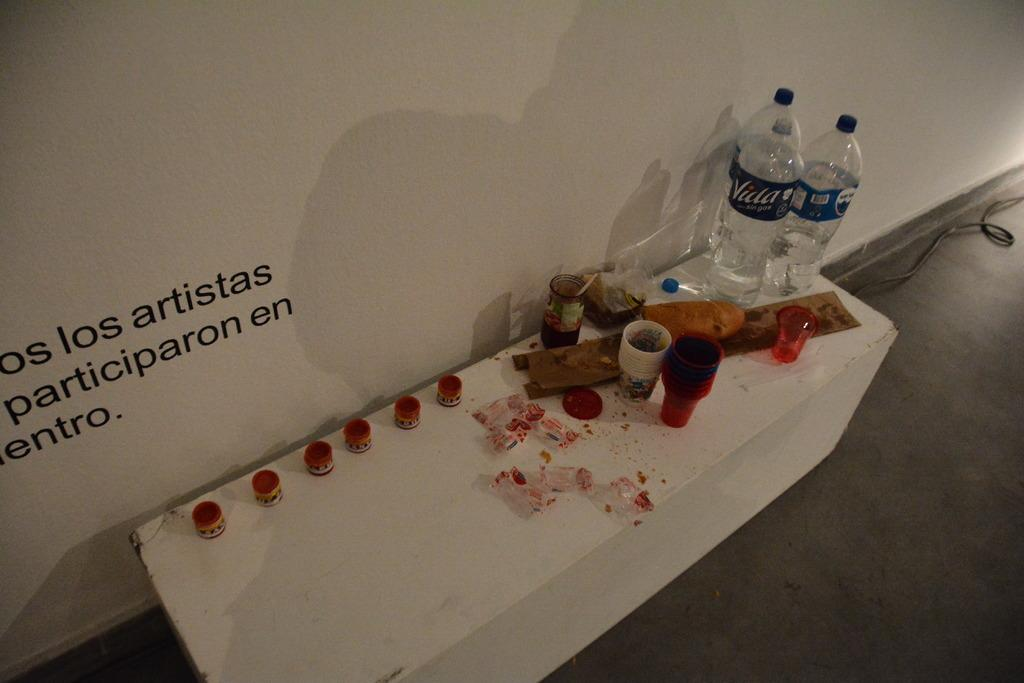<image>
Give a short and clear explanation of the subsequent image. Two water bottles next to one another with a blue label that says VIDA. 